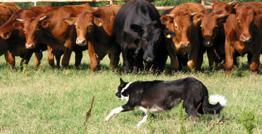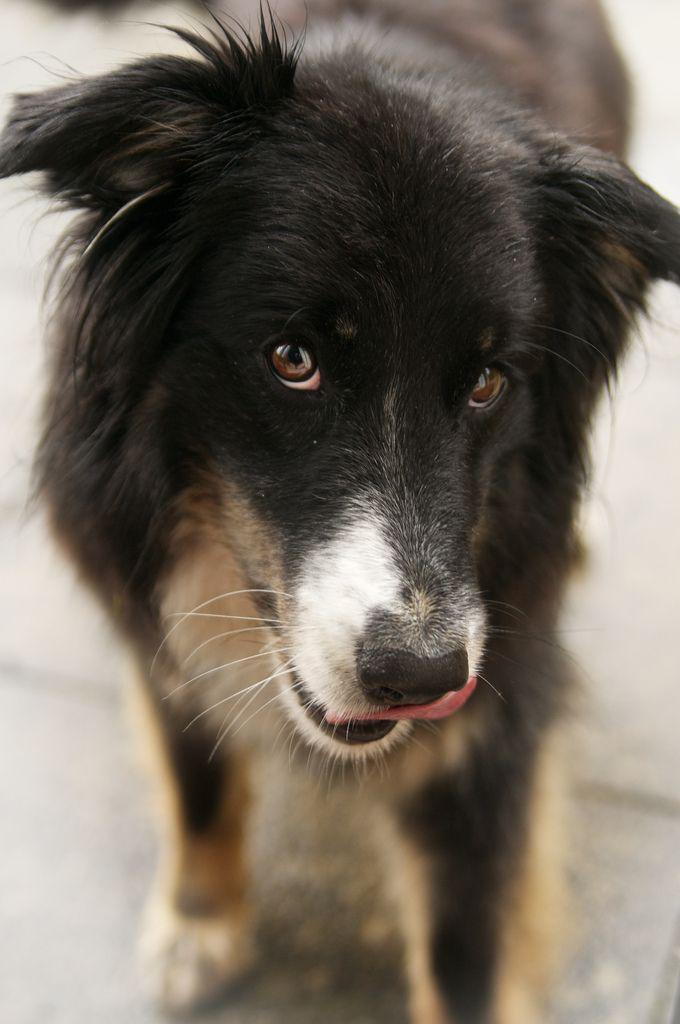The first image is the image on the left, the second image is the image on the right. Assess this claim about the two images: "One of the dogs is lying on grass with its head up.". Correct or not? Answer yes or no. No. The first image is the image on the left, the second image is the image on the right. Assess this claim about the two images: "There is one border calling laying down in the grass.". Correct or not? Answer yes or no. No. 